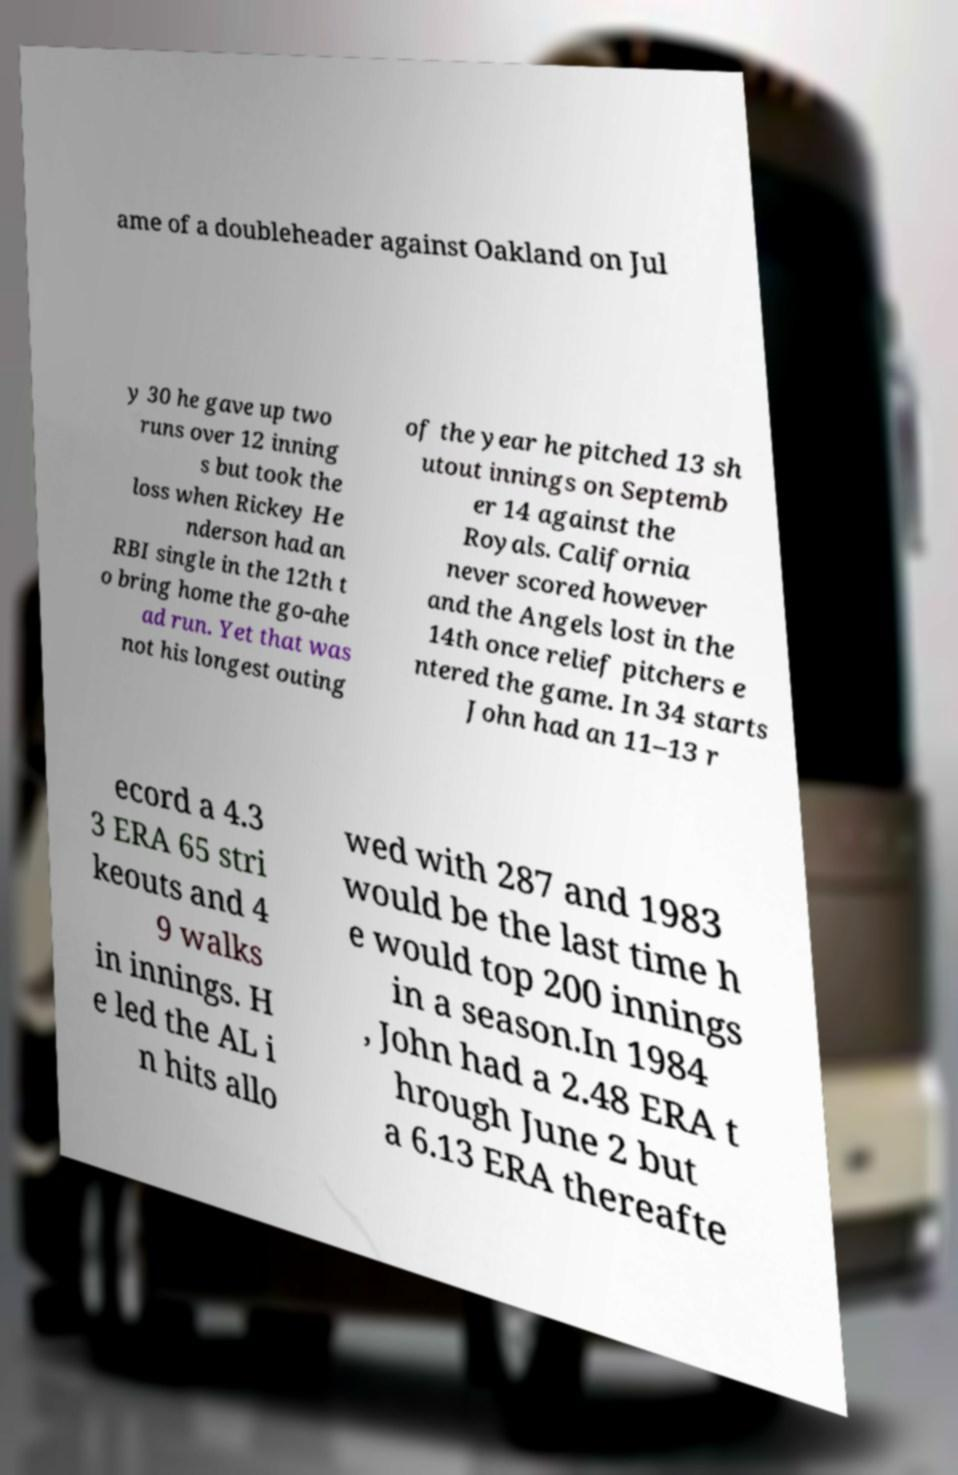I need the written content from this picture converted into text. Can you do that? ame of a doubleheader against Oakland on Jul y 30 he gave up two runs over 12 inning s but took the loss when Rickey He nderson had an RBI single in the 12th t o bring home the go-ahe ad run. Yet that was not his longest outing of the year he pitched 13 sh utout innings on Septemb er 14 against the Royals. California never scored however and the Angels lost in the 14th once relief pitchers e ntered the game. In 34 starts John had an 11–13 r ecord a 4.3 3 ERA 65 stri keouts and 4 9 walks in innings. H e led the AL i n hits allo wed with 287 and 1983 would be the last time h e would top 200 innings in a season.In 1984 , John had a 2.48 ERA t hrough June 2 but a 6.13 ERA thereafte 